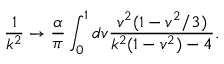Convert formula to latex. <formula><loc_0><loc_0><loc_500><loc_500>\frac { 1 } { k ^ { 2 } } \rightarrow \frac { \alpha } { \pi } \int _ { 0 } ^ { 1 } d v \frac { v ^ { 2 } ( 1 - v ^ { 2 } / 3 ) } { k ^ { 2 } ( 1 - v ^ { 2 } ) - 4 } .</formula> 